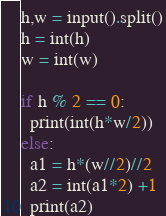<code> <loc_0><loc_0><loc_500><loc_500><_Python_>h,w = input().split()
h = int(h)
w = int(w)

if h % 2 == 0:
  print(int(h*w/2))
else:
  a1 = h*(w//2)//2
  a2 = int(a1*2) +1
  print(a2)
</code> 